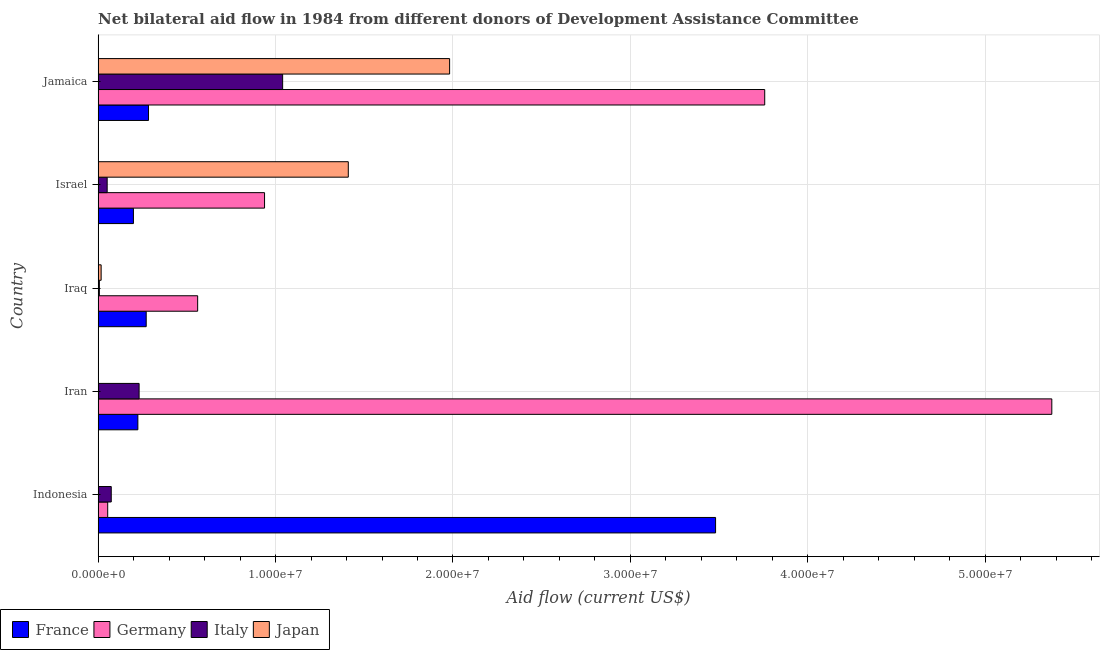How many different coloured bars are there?
Keep it short and to the point. 4. Are the number of bars per tick equal to the number of legend labels?
Your answer should be very brief. No. How many bars are there on the 5th tick from the top?
Keep it short and to the point. 3. How many bars are there on the 3rd tick from the bottom?
Provide a succinct answer. 4. What is the label of the 1st group of bars from the top?
Give a very brief answer. Jamaica. In how many cases, is the number of bars for a given country not equal to the number of legend labels?
Provide a succinct answer. 2. What is the amount of aid given by france in Jamaica?
Provide a short and direct response. 2.84e+06. Across all countries, what is the maximum amount of aid given by japan?
Provide a succinct answer. 1.98e+07. Across all countries, what is the minimum amount of aid given by italy?
Your answer should be very brief. 7.00e+04. In which country was the amount of aid given by germany maximum?
Ensure brevity in your answer.  Iran. What is the total amount of aid given by italy in the graph?
Your answer should be very brief. 1.40e+07. What is the difference between the amount of aid given by italy in Iraq and that in Israel?
Offer a terse response. -4.40e+05. What is the difference between the amount of aid given by germany in Jamaica and the amount of aid given by japan in Indonesia?
Provide a short and direct response. 3.76e+07. What is the average amount of aid given by france per country?
Your answer should be very brief. 8.92e+06. What is the difference between the amount of aid given by italy and amount of aid given by france in Iran?
Provide a short and direct response. 7.00e+04. What is the ratio of the amount of aid given by france in Iraq to that in Jamaica?
Make the answer very short. 0.95. What is the difference between the highest and the second highest amount of aid given by japan?
Offer a terse response. 5.71e+06. What is the difference between the highest and the lowest amount of aid given by italy?
Offer a terse response. 1.03e+07. In how many countries, is the amount of aid given by italy greater than the average amount of aid given by italy taken over all countries?
Make the answer very short. 1. Are all the bars in the graph horizontal?
Keep it short and to the point. Yes. How many countries are there in the graph?
Offer a very short reply. 5. What is the difference between two consecutive major ticks on the X-axis?
Provide a short and direct response. 1.00e+07. Are the values on the major ticks of X-axis written in scientific E-notation?
Provide a succinct answer. Yes. Does the graph contain any zero values?
Offer a very short reply. Yes. Does the graph contain grids?
Provide a succinct answer. Yes. How are the legend labels stacked?
Keep it short and to the point. Horizontal. What is the title of the graph?
Keep it short and to the point. Net bilateral aid flow in 1984 from different donors of Development Assistance Committee. Does "Plant species" appear as one of the legend labels in the graph?
Offer a very short reply. No. What is the label or title of the X-axis?
Provide a short and direct response. Aid flow (current US$). What is the label or title of the Y-axis?
Offer a terse response. Country. What is the Aid flow (current US$) in France in Indonesia?
Your answer should be compact. 3.48e+07. What is the Aid flow (current US$) in Germany in Indonesia?
Provide a short and direct response. 5.40e+05. What is the Aid flow (current US$) of Italy in Indonesia?
Keep it short and to the point. 7.40e+05. What is the Aid flow (current US$) in France in Iran?
Offer a very short reply. 2.24e+06. What is the Aid flow (current US$) in Germany in Iran?
Ensure brevity in your answer.  5.38e+07. What is the Aid flow (current US$) in Italy in Iran?
Your answer should be compact. 2.31e+06. What is the Aid flow (current US$) in France in Iraq?
Make the answer very short. 2.71e+06. What is the Aid flow (current US$) of Germany in Iraq?
Your response must be concise. 5.61e+06. What is the Aid flow (current US$) in France in Israel?
Make the answer very short. 1.99e+06. What is the Aid flow (current US$) of Germany in Israel?
Keep it short and to the point. 9.38e+06. What is the Aid flow (current US$) of Italy in Israel?
Ensure brevity in your answer.  5.10e+05. What is the Aid flow (current US$) of Japan in Israel?
Provide a short and direct response. 1.41e+07. What is the Aid flow (current US$) in France in Jamaica?
Keep it short and to the point. 2.84e+06. What is the Aid flow (current US$) in Germany in Jamaica?
Make the answer very short. 3.76e+07. What is the Aid flow (current US$) of Italy in Jamaica?
Give a very brief answer. 1.04e+07. What is the Aid flow (current US$) in Japan in Jamaica?
Provide a short and direct response. 1.98e+07. Across all countries, what is the maximum Aid flow (current US$) of France?
Make the answer very short. 3.48e+07. Across all countries, what is the maximum Aid flow (current US$) in Germany?
Your answer should be very brief. 5.38e+07. Across all countries, what is the maximum Aid flow (current US$) of Italy?
Offer a terse response. 1.04e+07. Across all countries, what is the maximum Aid flow (current US$) in Japan?
Give a very brief answer. 1.98e+07. Across all countries, what is the minimum Aid flow (current US$) of France?
Your response must be concise. 1.99e+06. Across all countries, what is the minimum Aid flow (current US$) of Germany?
Give a very brief answer. 5.40e+05. Across all countries, what is the minimum Aid flow (current US$) of Italy?
Ensure brevity in your answer.  7.00e+04. What is the total Aid flow (current US$) of France in the graph?
Make the answer very short. 4.46e+07. What is the total Aid flow (current US$) in Germany in the graph?
Give a very brief answer. 1.07e+08. What is the total Aid flow (current US$) in Italy in the graph?
Make the answer very short. 1.40e+07. What is the total Aid flow (current US$) in Japan in the graph?
Give a very brief answer. 3.41e+07. What is the difference between the Aid flow (current US$) of France in Indonesia and that in Iran?
Your answer should be compact. 3.26e+07. What is the difference between the Aid flow (current US$) of Germany in Indonesia and that in Iran?
Ensure brevity in your answer.  -5.32e+07. What is the difference between the Aid flow (current US$) of Italy in Indonesia and that in Iran?
Give a very brief answer. -1.57e+06. What is the difference between the Aid flow (current US$) in France in Indonesia and that in Iraq?
Give a very brief answer. 3.21e+07. What is the difference between the Aid flow (current US$) of Germany in Indonesia and that in Iraq?
Your answer should be compact. -5.07e+06. What is the difference between the Aid flow (current US$) in Italy in Indonesia and that in Iraq?
Provide a short and direct response. 6.70e+05. What is the difference between the Aid flow (current US$) in France in Indonesia and that in Israel?
Ensure brevity in your answer.  3.28e+07. What is the difference between the Aid flow (current US$) in Germany in Indonesia and that in Israel?
Offer a very short reply. -8.84e+06. What is the difference between the Aid flow (current US$) in Italy in Indonesia and that in Israel?
Offer a very short reply. 2.30e+05. What is the difference between the Aid flow (current US$) in France in Indonesia and that in Jamaica?
Ensure brevity in your answer.  3.20e+07. What is the difference between the Aid flow (current US$) in Germany in Indonesia and that in Jamaica?
Offer a very short reply. -3.70e+07. What is the difference between the Aid flow (current US$) in Italy in Indonesia and that in Jamaica?
Your answer should be very brief. -9.66e+06. What is the difference between the Aid flow (current US$) in France in Iran and that in Iraq?
Offer a very short reply. -4.70e+05. What is the difference between the Aid flow (current US$) of Germany in Iran and that in Iraq?
Give a very brief answer. 4.81e+07. What is the difference between the Aid flow (current US$) in Italy in Iran and that in Iraq?
Keep it short and to the point. 2.24e+06. What is the difference between the Aid flow (current US$) in France in Iran and that in Israel?
Ensure brevity in your answer.  2.50e+05. What is the difference between the Aid flow (current US$) of Germany in Iran and that in Israel?
Offer a very short reply. 4.44e+07. What is the difference between the Aid flow (current US$) of Italy in Iran and that in Israel?
Give a very brief answer. 1.80e+06. What is the difference between the Aid flow (current US$) of France in Iran and that in Jamaica?
Offer a terse response. -6.00e+05. What is the difference between the Aid flow (current US$) of Germany in Iran and that in Jamaica?
Ensure brevity in your answer.  1.62e+07. What is the difference between the Aid flow (current US$) of Italy in Iran and that in Jamaica?
Provide a succinct answer. -8.09e+06. What is the difference between the Aid flow (current US$) of France in Iraq and that in Israel?
Your answer should be very brief. 7.20e+05. What is the difference between the Aid flow (current US$) in Germany in Iraq and that in Israel?
Your response must be concise. -3.77e+06. What is the difference between the Aid flow (current US$) in Italy in Iraq and that in Israel?
Offer a very short reply. -4.40e+05. What is the difference between the Aid flow (current US$) in Japan in Iraq and that in Israel?
Your answer should be very brief. -1.39e+07. What is the difference between the Aid flow (current US$) in France in Iraq and that in Jamaica?
Your response must be concise. -1.30e+05. What is the difference between the Aid flow (current US$) in Germany in Iraq and that in Jamaica?
Offer a very short reply. -3.20e+07. What is the difference between the Aid flow (current US$) of Italy in Iraq and that in Jamaica?
Provide a succinct answer. -1.03e+07. What is the difference between the Aid flow (current US$) of Japan in Iraq and that in Jamaica?
Keep it short and to the point. -1.96e+07. What is the difference between the Aid flow (current US$) of France in Israel and that in Jamaica?
Offer a very short reply. -8.50e+05. What is the difference between the Aid flow (current US$) in Germany in Israel and that in Jamaica?
Keep it short and to the point. -2.82e+07. What is the difference between the Aid flow (current US$) in Italy in Israel and that in Jamaica?
Provide a short and direct response. -9.89e+06. What is the difference between the Aid flow (current US$) of Japan in Israel and that in Jamaica?
Your answer should be compact. -5.71e+06. What is the difference between the Aid flow (current US$) of France in Indonesia and the Aid flow (current US$) of Germany in Iran?
Ensure brevity in your answer.  -1.90e+07. What is the difference between the Aid flow (current US$) of France in Indonesia and the Aid flow (current US$) of Italy in Iran?
Offer a very short reply. 3.25e+07. What is the difference between the Aid flow (current US$) in Germany in Indonesia and the Aid flow (current US$) in Italy in Iran?
Ensure brevity in your answer.  -1.77e+06. What is the difference between the Aid flow (current US$) of France in Indonesia and the Aid flow (current US$) of Germany in Iraq?
Keep it short and to the point. 2.92e+07. What is the difference between the Aid flow (current US$) of France in Indonesia and the Aid flow (current US$) of Italy in Iraq?
Ensure brevity in your answer.  3.47e+07. What is the difference between the Aid flow (current US$) of France in Indonesia and the Aid flow (current US$) of Japan in Iraq?
Give a very brief answer. 3.46e+07. What is the difference between the Aid flow (current US$) in Germany in Indonesia and the Aid flow (current US$) in Italy in Iraq?
Ensure brevity in your answer.  4.70e+05. What is the difference between the Aid flow (current US$) of Italy in Indonesia and the Aid flow (current US$) of Japan in Iraq?
Ensure brevity in your answer.  5.70e+05. What is the difference between the Aid flow (current US$) of France in Indonesia and the Aid flow (current US$) of Germany in Israel?
Give a very brief answer. 2.54e+07. What is the difference between the Aid flow (current US$) in France in Indonesia and the Aid flow (current US$) in Italy in Israel?
Give a very brief answer. 3.43e+07. What is the difference between the Aid flow (current US$) of France in Indonesia and the Aid flow (current US$) of Japan in Israel?
Offer a terse response. 2.07e+07. What is the difference between the Aid flow (current US$) in Germany in Indonesia and the Aid flow (current US$) in Italy in Israel?
Make the answer very short. 3.00e+04. What is the difference between the Aid flow (current US$) in Germany in Indonesia and the Aid flow (current US$) in Japan in Israel?
Give a very brief answer. -1.36e+07. What is the difference between the Aid flow (current US$) in Italy in Indonesia and the Aid flow (current US$) in Japan in Israel?
Offer a very short reply. -1.34e+07. What is the difference between the Aid flow (current US$) in France in Indonesia and the Aid flow (current US$) in Germany in Jamaica?
Your response must be concise. -2.77e+06. What is the difference between the Aid flow (current US$) of France in Indonesia and the Aid flow (current US$) of Italy in Jamaica?
Keep it short and to the point. 2.44e+07. What is the difference between the Aid flow (current US$) in France in Indonesia and the Aid flow (current US$) in Japan in Jamaica?
Your answer should be very brief. 1.50e+07. What is the difference between the Aid flow (current US$) in Germany in Indonesia and the Aid flow (current US$) in Italy in Jamaica?
Your response must be concise. -9.86e+06. What is the difference between the Aid flow (current US$) in Germany in Indonesia and the Aid flow (current US$) in Japan in Jamaica?
Make the answer very short. -1.93e+07. What is the difference between the Aid flow (current US$) of Italy in Indonesia and the Aid flow (current US$) of Japan in Jamaica?
Your response must be concise. -1.91e+07. What is the difference between the Aid flow (current US$) of France in Iran and the Aid flow (current US$) of Germany in Iraq?
Your response must be concise. -3.37e+06. What is the difference between the Aid flow (current US$) in France in Iran and the Aid flow (current US$) in Italy in Iraq?
Give a very brief answer. 2.17e+06. What is the difference between the Aid flow (current US$) in France in Iran and the Aid flow (current US$) in Japan in Iraq?
Keep it short and to the point. 2.07e+06. What is the difference between the Aid flow (current US$) in Germany in Iran and the Aid flow (current US$) in Italy in Iraq?
Your response must be concise. 5.37e+07. What is the difference between the Aid flow (current US$) of Germany in Iran and the Aid flow (current US$) of Japan in Iraq?
Provide a short and direct response. 5.36e+07. What is the difference between the Aid flow (current US$) of Italy in Iran and the Aid flow (current US$) of Japan in Iraq?
Ensure brevity in your answer.  2.14e+06. What is the difference between the Aid flow (current US$) of France in Iran and the Aid flow (current US$) of Germany in Israel?
Provide a short and direct response. -7.14e+06. What is the difference between the Aid flow (current US$) of France in Iran and the Aid flow (current US$) of Italy in Israel?
Give a very brief answer. 1.73e+06. What is the difference between the Aid flow (current US$) of France in Iran and the Aid flow (current US$) of Japan in Israel?
Your answer should be very brief. -1.19e+07. What is the difference between the Aid flow (current US$) in Germany in Iran and the Aid flow (current US$) in Italy in Israel?
Your answer should be compact. 5.32e+07. What is the difference between the Aid flow (current US$) in Germany in Iran and the Aid flow (current US$) in Japan in Israel?
Your answer should be compact. 3.96e+07. What is the difference between the Aid flow (current US$) in Italy in Iran and the Aid flow (current US$) in Japan in Israel?
Give a very brief answer. -1.18e+07. What is the difference between the Aid flow (current US$) in France in Iran and the Aid flow (current US$) in Germany in Jamaica?
Ensure brevity in your answer.  -3.53e+07. What is the difference between the Aid flow (current US$) of France in Iran and the Aid flow (current US$) of Italy in Jamaica?
Provide a short and direct response. -8.16e+06. What is the difference between the Aid flow (current US$) of France in Iran and the Aid flow (current US$) of Japan in Jamaica?
Offer a very short reply. -1.76e+07. What is the difference between the Aid flow (current US$) in Germany in Iran and the Aid flow (current US$) in Italy in Jamaica?
Give a very brief answer. 4.34e+07. What is the difference between the Aid flow (current US$) of Germany in Iran and the Aid flow (current US$) of Japan in Jamaica?
Offer a terse response. 3.39e+07. What is the difference between the Aid flow (current US$) in Italy in Iran and the Aid flow (current US$) in Japan in Jamaica?
Your response must be concise. -1.75e+07. What is the difference between the Aid flow (current US$) of France in Iraq and the Aid flow (current US$) of Germany in Israel?
Give a very brief answer. -6.67e+06. What is the difference between the Aid flow (current US$) of France in Iraq and the Aid flow (current US$) of Italy in Israel?
Provide a short and direct response. 2.20e+06. What is the difference between the Aid flow (current US$) of France in Iraq and the Aid flow (current US$) of Japan in Israel?
Your answer should be compact. -1.14e+07. What is the difference between the Aid flow (current US$) in Germany in Iraq and the Aid flow (current US$) in Italy in Israel?
Keep it short and to the point. 5.10e+06. What is the difference between the Aid flow (current US$) in Germany in Iraq and the Aid flow (current US$) in Japan in Israel?
Your answer should be compact. -8.49e+06. What is the difference between the Aid flow (current US$) of Italy in Iraq and the Aid flow (current US$) of Japan in Israel?
Ensure brevity in your answer.  -1.40e+07. What is the difference between the Aid flow (current US$) in France in Iraq and the Aid flow (current US$) in Germany in Jamaica?
Your answer should be compact. -3.49e+07. What is the difference between the Aid flow (current US$) of France in Iraq and the Aid flow (current US$) of Italy in Jamaica?
Keep it short and to the point. -7.69e+06. What is the difference between the Aid flow (current US$) in France in Iraq and the Aid flow (current US$) in Japan in Jamaica?
Give a very brief answer. -1.71e+07. What is the difference between the Aid flow (current US$) in Germany in Iraq and the Aid flow (current US$) in Italy in Jamaica?
Offer a terse response. -4.79e+06. What is the difference between the Aid flow (current US$) in Germany in Iraq and the Aid flow (current US$) in Japan in Jamaica?
Make the answer very short. -1.42e+07. What is the difference between the Aid flow (current US$) in Italy in Iraq and the Aid flow (current US$) in Japan in Jamaica?
Your answer should be compact. -1.97e+07. What is the difference between the Aid flow (current US$) of France in Israel and the Aid flow (current US$) of Germany in Jamaica?
Give a very brief answer. -3.56e+07. What is the difference between the Aid flow (current US$) of France in Israel and the Aid flow (current US$) of Italy in Jamaica?
Provide a succinct answer. -8.41e+06. What is the difference between the Aid flow (current US$) of France in Israel and the Aid flow (current US$) of Japan in Jamaica?
Your answer should be very brief. -1.78e+07. What is the difference between the Aid flow (current US$) in Germany in Israel and the Aid flow (current US$) in Italy in Jamaica?
Provide a succinct answer. -1.02e+06. What is the difference between the Aid flow (current US$) in Germany in Israel and the Aid flow (current US$) in Japan in Jamaica?
Make the answer very short. -1.04e+07. What is the difference between the Aid flow (current US$) in Italy in Israel and the Aid flow (current US$) in Japan in Jamaica?
Give a very brief answer. -1.93e+07. What is the average Aid flow (current US$) in France per country?
Your answer should be compact. 8.92e+06. What is the average Aid flow (current US$) in Germany per country?
Give a very brief answer. 2.14e+07. What is the average Aid flow (current US$) of Italy per country?
Ensure brevity in your answer.  2.81e+06. What is the average Aid flow (current US$) in Japan per country?
Ensure brevity in your answer.  6.82e+06. What is the difference between the Aid flow (current US$) in France and Aid flow (current US$) in Germany in Indonesia?
Make the answer very short. 3.43e+07. What is the difference between the Aid flow (current US$) in France and Aid flow (current US$) in Italy in Indonesia?
Provide a short and direct response. 3.41e+07. What is the difference between the Aid flow (current US$) of Germany and Aid flow (current US$) of Italy in Indonesia?
Offer a terse response. -2.00e+05. What is the difference between the Aid flow (current US$) in France and Aid flow (current US$) in Germany in Iran?
Ensure brevity in your answer.  -5.15e+07. What is the difference between the Aid flow (current US$) of France and Aid flow (current US$) of Italy in Iran?
Make the answer very short. -7.00e+04. What is the difference between the Aid flow (current US$) in Germany and Aid flow (current US$) in Italy in Iran?
Provide a short and direct response. 5.14e+07. What is the difference between the Aid flow (current US$) in France and Aid flow (current US$) in Germany in Iraq?
Keep it short and to the point. -2.90e+06. What is the difference between the Aid flow (current US$) of France and Aid flow (current US$) of Italy in Iraq?
Offer a very short reply. 2.64e+06. What is the difference between the Aid flow (current US$) of France and Aid flow (current US$) of Japan in Iraq?
Ensure brevity in your answer.  2.54e+06. What is the difference between the Aid flow (current US$) in Germany and Aid flow (current US$) in Italy in Iraq?
Ensure brevity in your answer.  5.54e+06. What is the difference between the Aid flow (current US$) of Germany and Aid flow (current US$) of Japan in Iraq?
Your response must be concise. 5.44e+06. What is the difference between the Aid flow (current US$) of France and Aid flow (current US$) of Germany in Israel?
Your answer should be very brief. -7.39e+06. What is the difference between the Aid flow (current US$) of France and Aid flow (current US$) of Italy in Israel?
Your answer should be compact. 1.48e+06. What is the difference between the Aid flow (current US$) in France and Aid flow (current US$) in Japan in Israel?
Offer a terse response. -1.21e+07. What is the difference between the Aid flow (current US$) in Germany and Aid flow (current US$) in Italy in Israel?
Provide a short and direct response. 8.87e+06. What is the difference between the Aid flow (current US$) of Germany and Aid flow (current US$) of Japan in Israel?
Ensure brevity in your answer.  -4.72e+06. What is the difference between the Aid flow (current US$) of Italy and Aid flow (current US$) of Japan in Israel?
Provide a succinct answer. -1.36e+07. What is the difference between the Aid flow (current US$) in France and Aid flow (current US$) in Germany in Jamaica?
Offer a very short reply. -3.47e+07. What is the difference between the Aid flow (current US$) of France and Aid flow (current US$) of Italy in Jamaica?
Your response must be concise. -7.56e+06. What is the difference between the Aid flow (current US$) in France and Aid flow (current US$) in Japan in Jamaica?
Ensure brevity in your answer.  -1.70e+07. What is the difference between the Aid flow (current US$) of Germany and Aid flow (current US$) of Italy in Jamaica?
Your answer should be compact. 2.72e+07. What is the difference between the Aid flow (current US$) in Germany and Aid flow (current US$) in Japan in Jamaica?
Your response must be concise. 1.78e+07. What is the difference between the Aid flow (current US$) of Italy and Aid flow (current US$) of Japan in Jamaica?
Provide a succinct answer. -9.41e+06. What is the ratio of the Aid flow (current US$) of France in Indonesia to that in Iran?
Your answer should be compact. 15.54. What is the ratio of the Aid flow (current US$) of Italy in Indonesia to that in Iran?
Provide a short and direct response. 0.32. What is the ratio of the Aid flow (current US$) of France in Indonesia to that in Iraq?
Your answer should be compact. 12.84. What is the ratio of the Aid flow (current US$) in Germany in Indonesia to that in Iraq?
Give a very brief answer. 0.1. What is the ratio of the Aid flow (current US$) of Italy in Indonesia to that in Iraq?
Provide a short and direct response. 10.57. What is the ratio of the Aid flow (current US$) in France in Indonesia to that in Israel?
Keep it short and to the point. 17.49. What is the ratio of the Aid flow (current US$) in Germany in Indonesia to that in Israel?
Provide a short and direct response. 0.06. What is the ratio of the Aid flow (current US$) of Italy in Indonesia to that in Israel?
Ensure brevity in your answer.  1.45. What is the ratio of the Aid flow (current US$) of France in Indonesia to that in Jamaica?
Your answer should be very brief. 12.25. What is the ratio of the Aid flow (current US$) in Germany in Indonesia to that in Jamaica?
Provide a succinct answer. 0.01. What is the ratio of the Aid flow (current US$) in Italy in Indonesia to that in Jamaica?
Give a very brief answer. 0.07. What is the ratio of the Aid flow (current US$) in France in Iran to that in Iraq?
Make the answer very short. 0.83. What is the ratio of the Aid flow (current US$) in Germany in Iran to that in Iraq?
Provide a short and direct response. 9.58. What is the ratio of the Aid flow (current US$) in France in Iran to that in Israel?
Offer a terse response. 1.13. What is the ratio of the Aid flow (current US$) in Germany in Iran to that in Israel?
Your answer should be compact. 5.73. What is the ratio of the Aid flow (current US$) in Italy in Iran to that in Israel?
Your answer should be compact. 4.53. What is the ratio of the Aid flow (current US$) of France in Iran to that in Jamaica?
Give a very brief answer. 0.79. What is the ratio of the Aid flow (current US$) of Germany in Iran to that in Jamaica?
Provide a short and direct response. 1.43. What is the ratio of the Aid flow (current US$) of Italy in Iran to that in Jamaica?
Make the answer very short. 0.22. What is the ratio of the Aid flow (current US$) in France in Iraq to that in Israel?
Your response must be concise. 1.36. What is the ratio of the Aid flow (current US$) of Germany in Iraq to that in Israel?
Provide a short and direct response. 0.6. What is the ratio of the Aid flow (current US$) in Italy in Iraq to that in Israel?
Provide a short and direct response. 0.14. What is the ratio of the Aid flow (current US$) of Japan in Iraq to that in Israel?
Provide a short and direct response. 0.01. What is the ratio of the Aid flow (current US$) in France in Iraq to that in Jamaica?
Your answer should be very brief. 0.95. What is the ratio of the Aid flow (current US$) in Germany in Iraq to that in Jamaica?
Your response must be concise. 0.15. What is the ratio of the Aid flow (current US$) in Italy in Iraq to that in Jamaica?
Give a very brief answer. 0.01. What is the ratio of the Aid flow (current US$) in Japan in Iraq to that in Jamaica?
Your answer should be very brief. 0.01. What is the ratio of the Aid flow (current US$) in France in Israel to that in Jamaica?
Your answer should be very brief. 0.7. What is the ratio of the Aid flow (current US$) of Germany in Israel to that in Jamaica?
Ensure brevity in your answer.  0.25. What is the ratio of the Aid flow (current US$) in Italy in Israel to that in Jamaica?
Give a very brief answer. 0.05. What is the ratio of the Aid flow (current US$) of Japan in Israel to that in Jamaica?
Offer a very short reply. 0.71. What is the difference between the highest and the second highest Aid flow (current US$) in France?
Keep it short and to the point. 3.20e+07. What is the difference between the highest and the second highest Aid flow (current US$) in Germany?
Your response must be concise. 1.62e+07. What is the difference between the highest and the second highest Aid flow (current US$) of Italy?
Provide a succinct answer. 8.09e+06. What is the difference between the highest and the second highest Aid flow (current US$) of Japan?
Keep it short and to the point. 5.71e+06. What is the difference between the highest and the lowest Aid flow (current US$) in France?
Provide a succinct answer. 3.28e+07. What is the difference between the highest and the lowest Aid flow (current US$) of Germany?
Ensure brevity in your answer.  5.32e+07. What is the difference between the highest and the lowest Aid flow (current US$) in Italy?
Your answer should be very brief. 1.03e+07. What is the difference between the highest and the lowest Aid flow (current US$) in Japan?
Your response must be concise. 1.98e+07. 